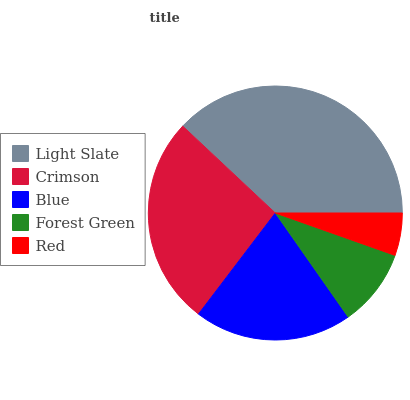Is Red the minimum?
Answer yes or no. Yes. Is Light Slate the maximum?
Answer yes or no. Yes. Is Crimson the minimum?
Answer yes or no. No. Is Crimson the maximum?
Answer yes or no. No. Is Light Slate greater than Crimson?
Answer yes or no. Yes. Is Crimson less than Light Slate?
Answer yes or no. Yes. Is Crimson greater than Light Slate?
Answer yes or no. No. Is Light Slate less than Crimson?
Answer yes or no. No. Is Blue the high median?
Answer yes or no. Yes. Is Blue the low median?
Answer yes or no. Yes. Is Light Slate the high median?
Answer yes or no. No. Is Light Slate the low median?
Answer yes or no. No. 